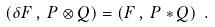Convert formula to latex. <formula><loc_0><loc_0><loc_500><loc_500>( \delta F \, , \, P \otimes Q ) = ( F \, , \, P * Q ) \ .</formula> 